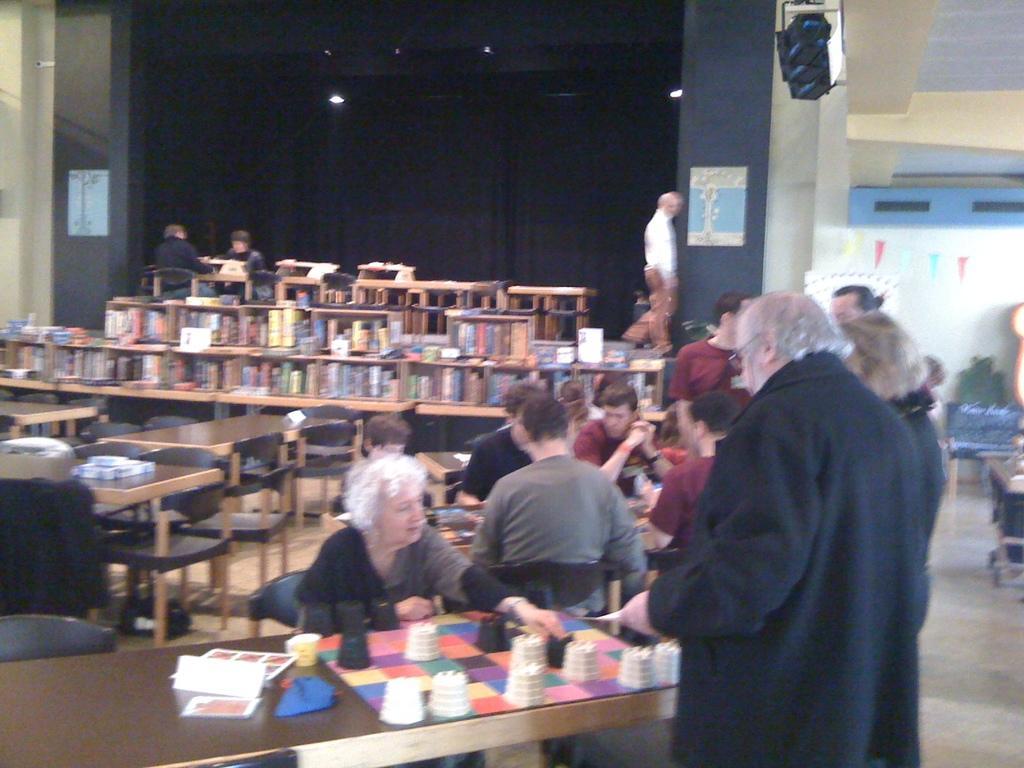How would you summarize this image in a sentence or two? This picture is of inside. In the foreground we can see a Man standing and a woman sitting on the chair. There is a table. In the center there are group of person sitting on the chairs. In the background we can see the table and some books placed on the top of the table. We can see the curtains. 